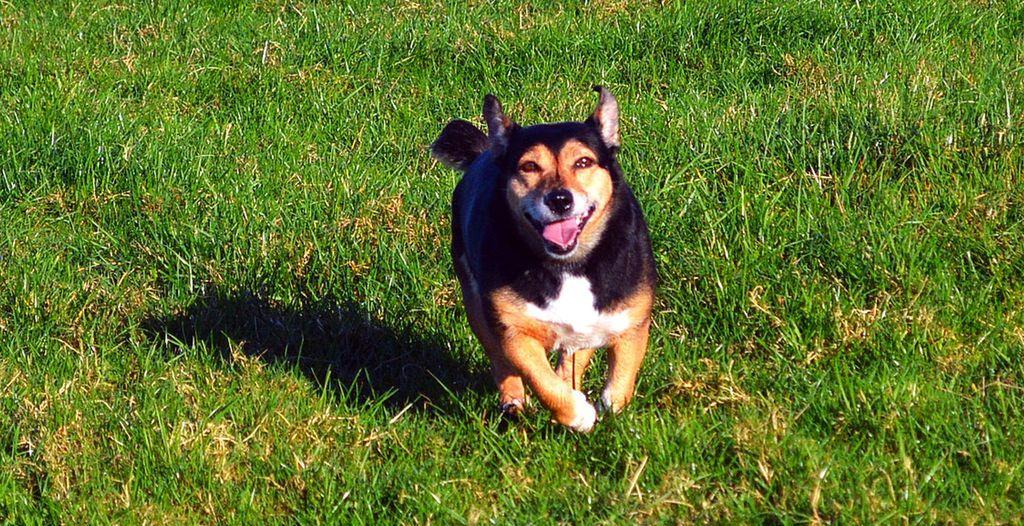Can you describe this image briefly? In this picture we can see a dog running on the ground and in the background we can see grass. 